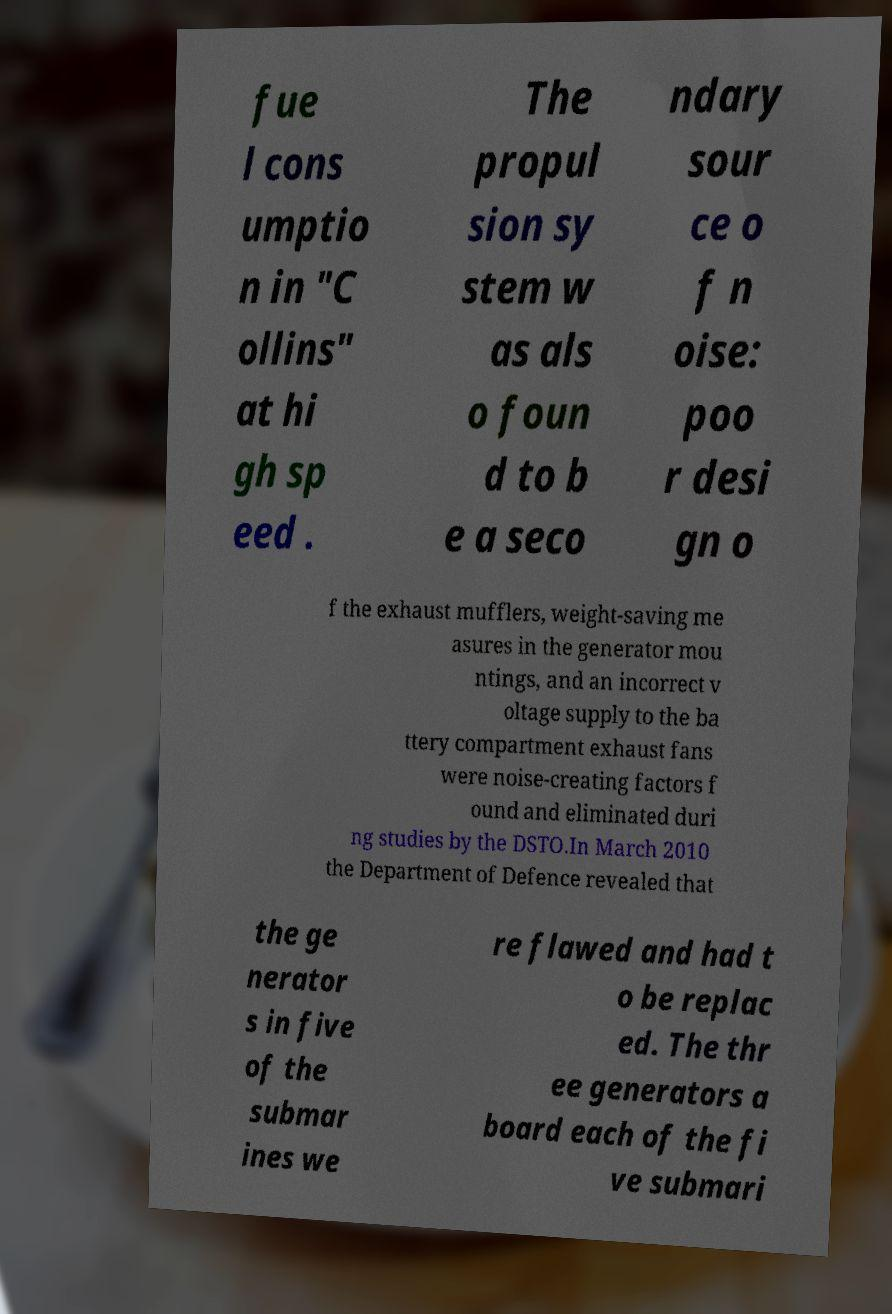Could you extract and type out the text from this image? fue l cons umptio n in "C ollins" at hi gh sp eed . The propul sion sy stem w as als o foun d to b e a seco ndary sour ce o f n oise: poo r desi gn o f the exhaust mufflers, weight-saving me asures in the generator mou ntings, and an incorrect v oltage supply to the ba ttery compartment exhaust fans were noise-creating factors f ound and eliminated duri ng studies by the DSTO.In March 2010 the Department of Defence revealed that the ge nerator s in five of the submar ines we re flawed and had t o be replac ed. The thr ee generators a board each of the fi ve submari 